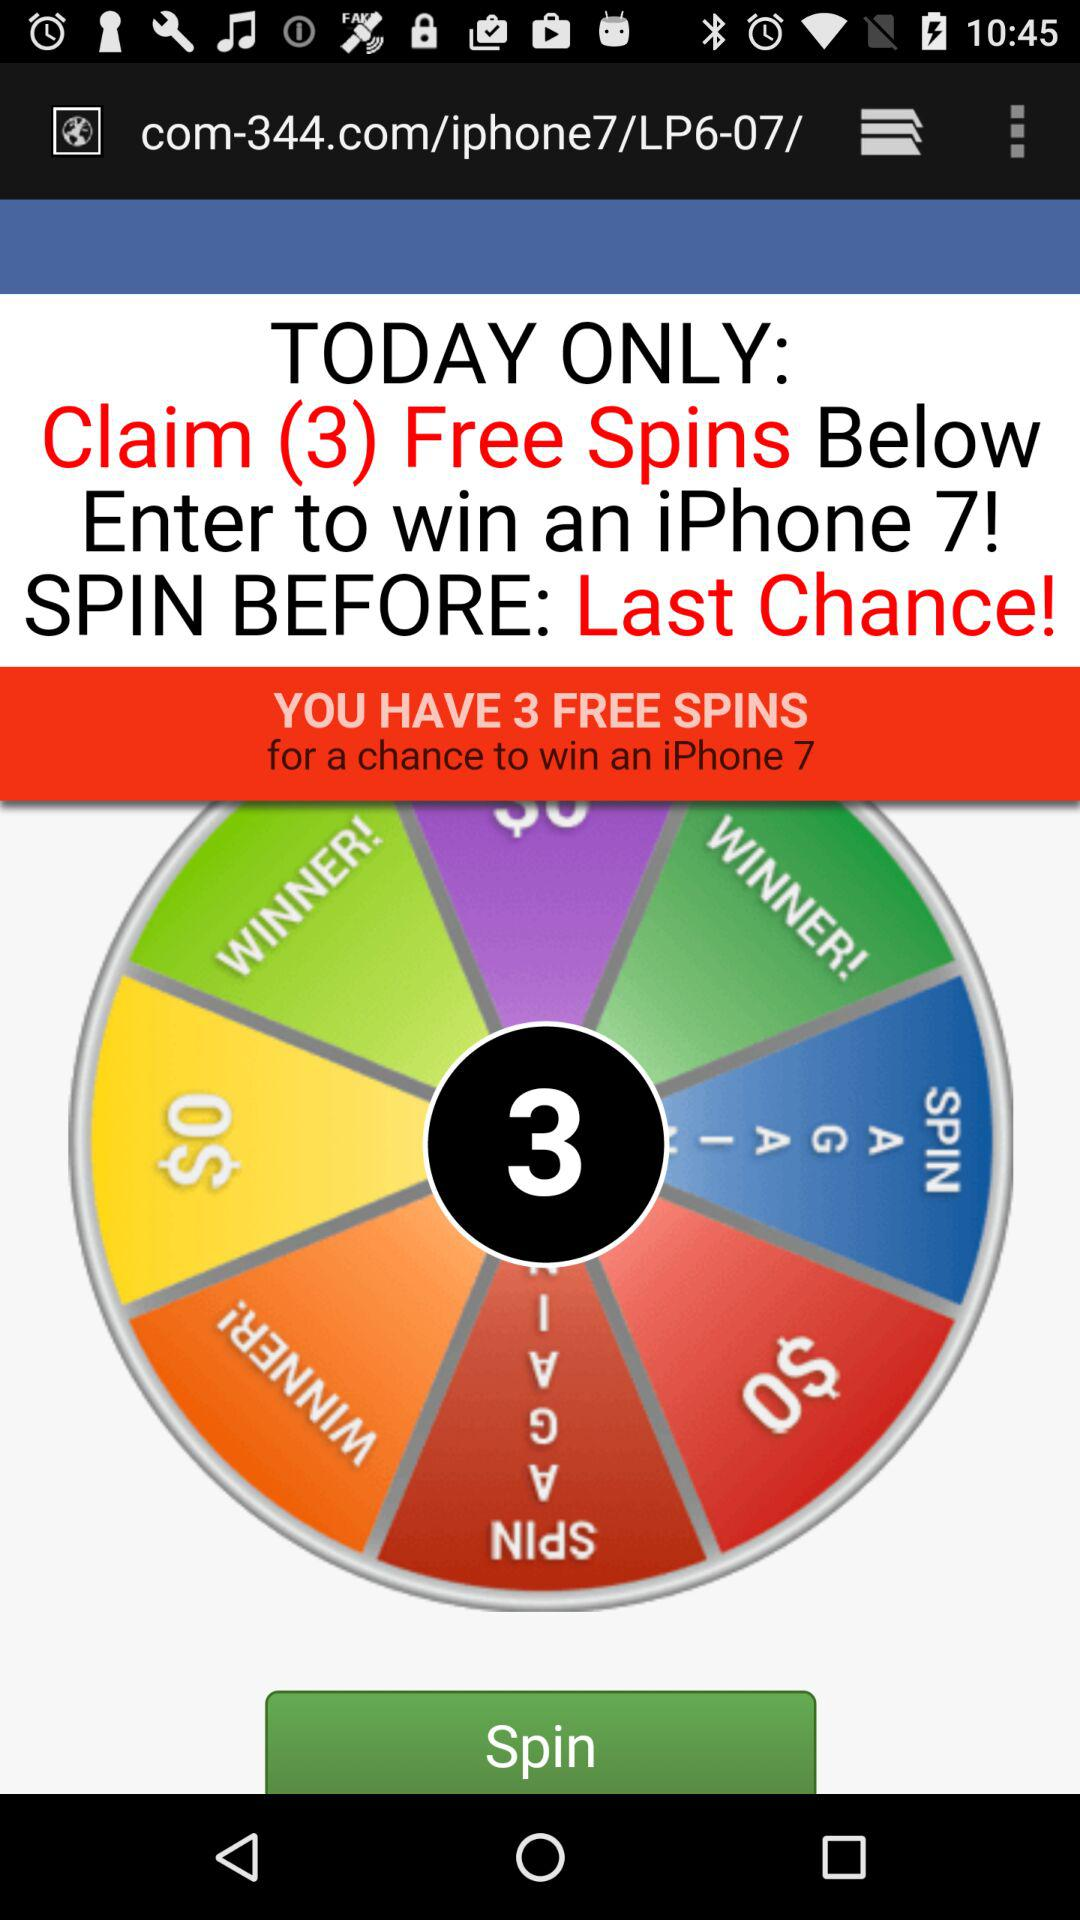How many free spins do I have?
Answer the question using a single word or phrase. 3 